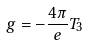<formula> <loc_0><loc_0><loc_500><loc_500>g = - \frac { 4 \pi } { e } T _ { 3 }</formula> 